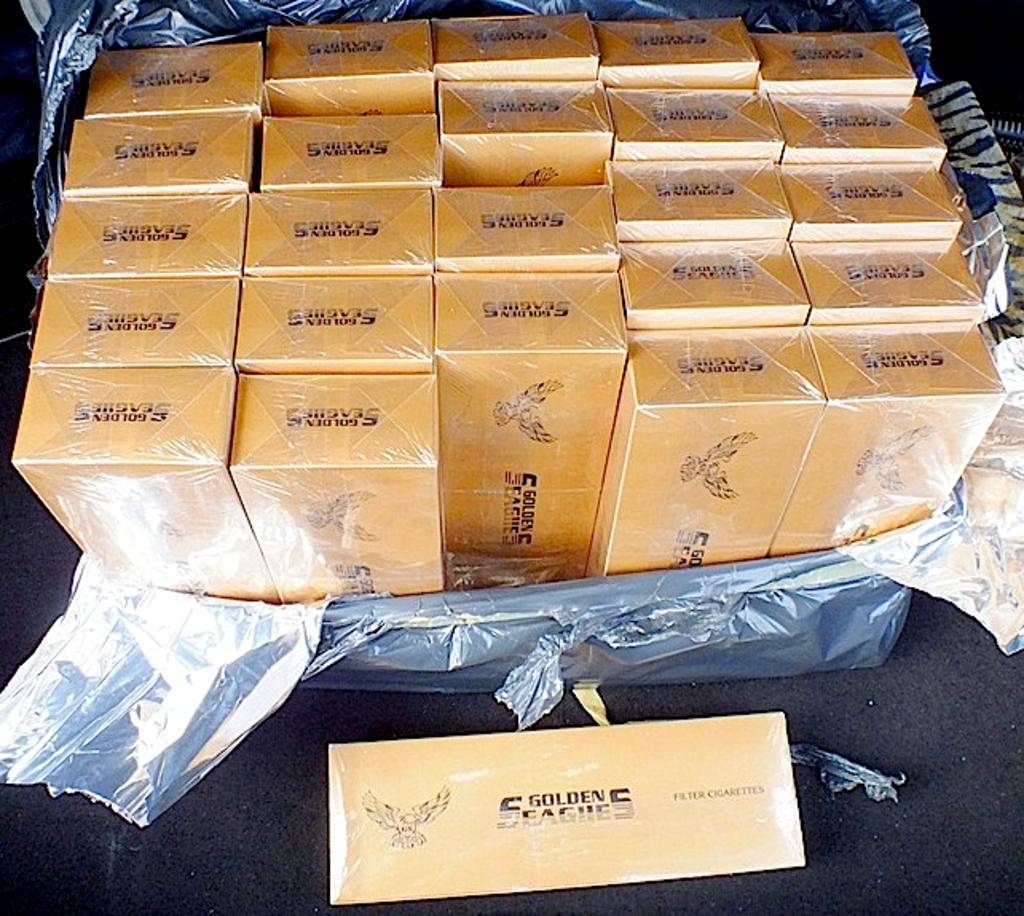Please provide a concise description of this image. At the bottom of the image there is a table. In the middle of the image there are many boxes covered with a polythene sheet and there is another box on the table. 